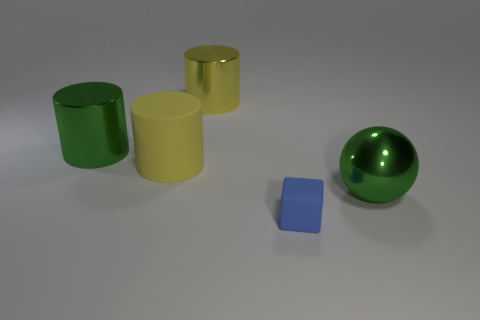Subtract all yellow rubber cylinders. How many cylinders are left? 2 Add 3 tiny brown rubber objects. How many objects exist? 8 Subtract all green cylinders. How many cylinders are left? 2 Subtract all cubes. How many objects are left? 4 Add 4 large yellow cylinders. How many large yellow cylinders exist? 6 Subtract 0 cyan blocks. How many objects are left? 5 Subtract 1 balls. How many balls are left? 0 Subtract all red blocks. Subtract all cyan balls. How many blocks are left? 1 Subtract all blue balls. How many purple cubes are left? 0 Subtract all green balls. Subtract all large yellow cylinders. How many objects are left? 2 